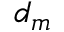<formula> <loc_0><loc_0><loc_500><loc_500>d _ { m }</formula> 